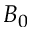<formula> <loc_0><loc_0><loc_500><loc_500>B _ { 0 }</formula> 